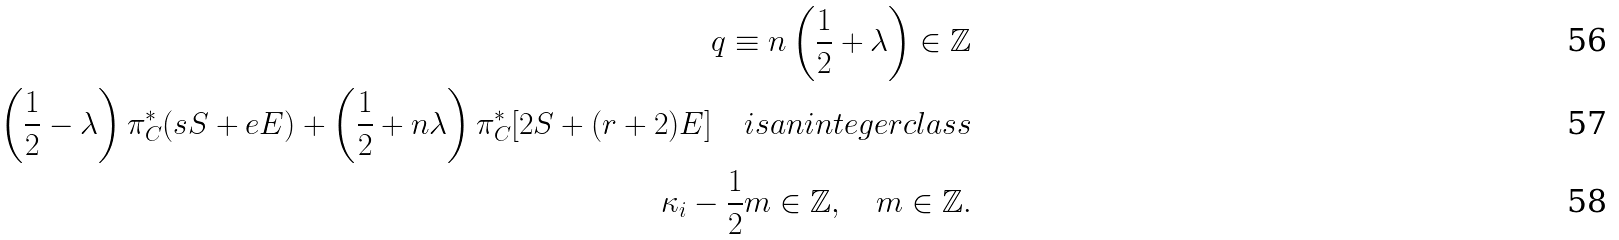Convert formula to latex. <formula><loc_0><loc_0><loc_500><loc_500>q \equiv n \left ( \frac { 1 } { 2 } + \lambda \right ) \in \mathbb { Z } \\ \left ( \frac { 1 } { 2 } - \lambda \right ) \pi ^ { * } _ { C } ( s S + e E ) + \left ( \frac { 1 } { 2 } + n \lambda \right ) \pi ^ { * } _ { C } [ 2 S + ( r + 2 ) E ] \quad i s a n i n t e g e r c l a s s \\ \kappa _ { i } - \frac { 1 } { 2 } m \in \mathbb { Z } , \quad m \in \mathbb { Z } .</formula> 